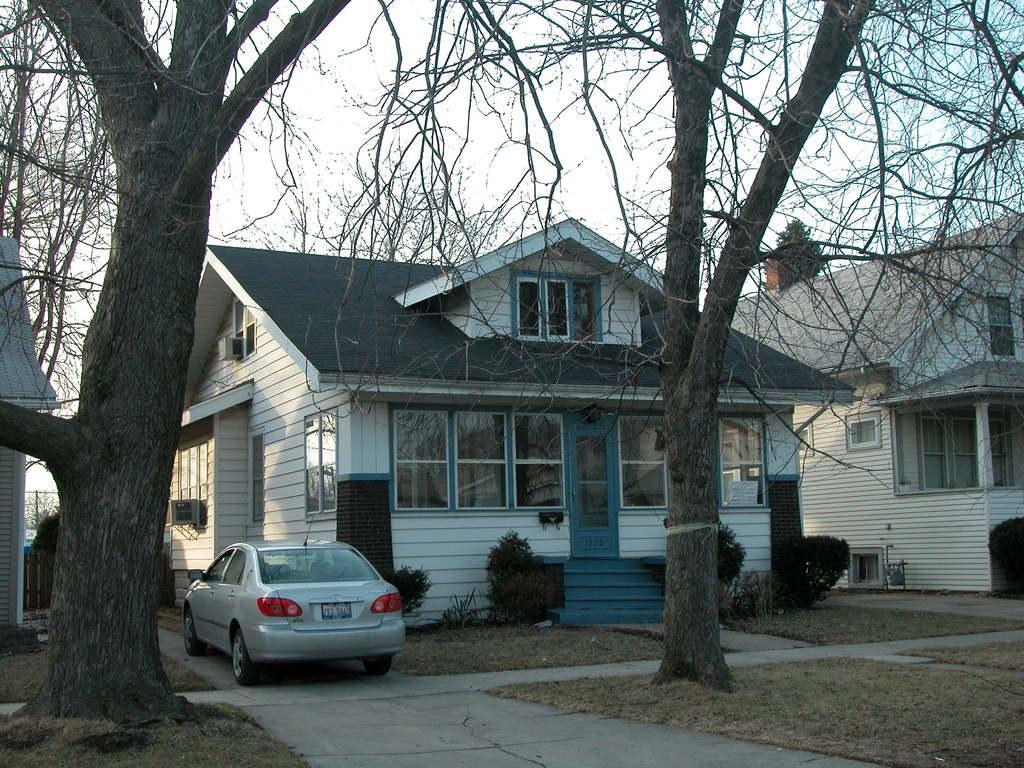In one or two sentences, can you explain what this image depicts? In this image we can see a car parked on the path. In the background we can see group of buildings ,trees and sky. 